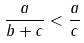Convert formula to latex. <formula><loc_0><loc_0><loc_500><loc_500>\frac { a } { b + c } < \frac { a } { c }</formula> 